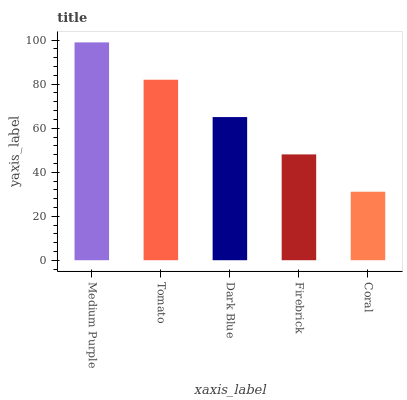Is Tomato the minimum?
Answer yes or no. No. Is Tomato the maximum?
Answer yes or no. No. Is Medium Purple greater than Tomato?
Answer yes or no. Yes. Is Tomato less than Medium Purple?
Answer yes or no. Yes. Is Tomato greater than Medium Purple?
Answer yes or no. No. Is Medium Purple less than Tomato?
Answer yes or no. No. Is Dark Blue the high median?
Answer yes or no. Yes. Is Dark Blue the low median?
Answer yes or no. Yes. Is Coral the high median?
Answer yes or no. No. Is Firebrick the low median?
Answer yes or no. No. 